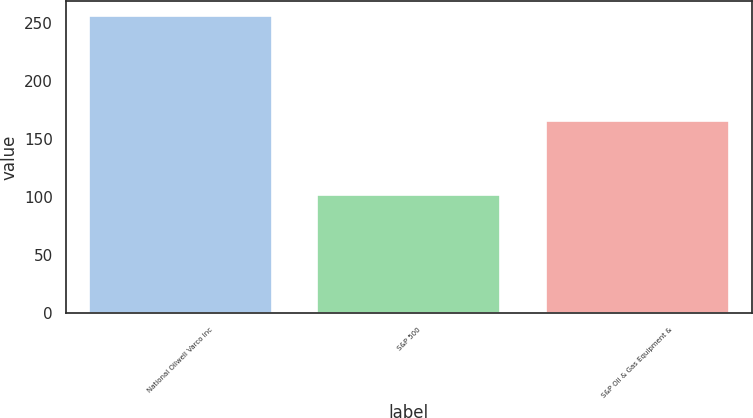Convert chart. <chart><loc_0><loc_0><loc_500><loc_500><bar_chart><fcel>National Oilwell Varco Inc<fcel>S&P 500<fcel>S&P Oil & Gas Equipment &<nl><fcel>256.26<fcel>102.11<fcel>165.61<nl></chart> 